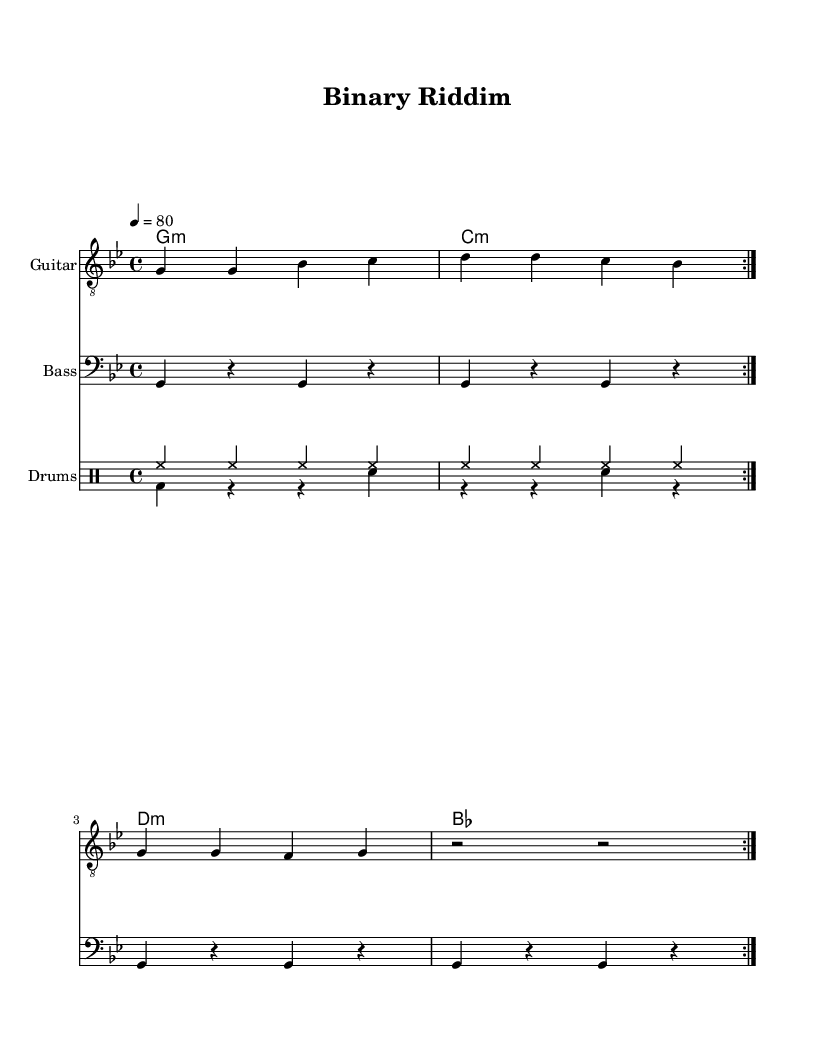What is the key signature of this music? The key signature is G minor, which corresponds to two flats in the key signature, B flat and E flat, visible on the staff.
Answer: G minor What is the time signature of this music? The time signature is four-four, indicated by the '4/4' at the beginning of the score, meaning there are four beats per measure.
Answer: 4/4 What is the tempo marking indicated in this sheet music? The tempo is set at 80 beats per minute, shown in the tempo section with '4 = 80', which guides the speed of the performance.
Answer: 80 Which instrument plays in the bass clef? The instrument that plays in the bass clef is the Bass, noted in the staff designation below the bass guitar part.
Answer: Bass How many times is the guitar phrase repeated? The guitar phrase is repeated two times, as indicated by the 'repeat volta 2' instruction above the staff for the guitar.
Answer: 2 What type of rhythm is predominantly used in the drum section? The rhythm used in the drum section is a combination of hi-hat and bass drum patterns, typical in reggae music, creating a syncopated feel with the kick and snare variations.
Answer: Syncopated What is the predominant musical style of this piece? The predominant musical style is Dub-influenced reggae, which is characterized by heavy rhythmic emphasis and instrumental focus, evident from the structure and instrumentation used.
Answer: Dub-influenced reggae 